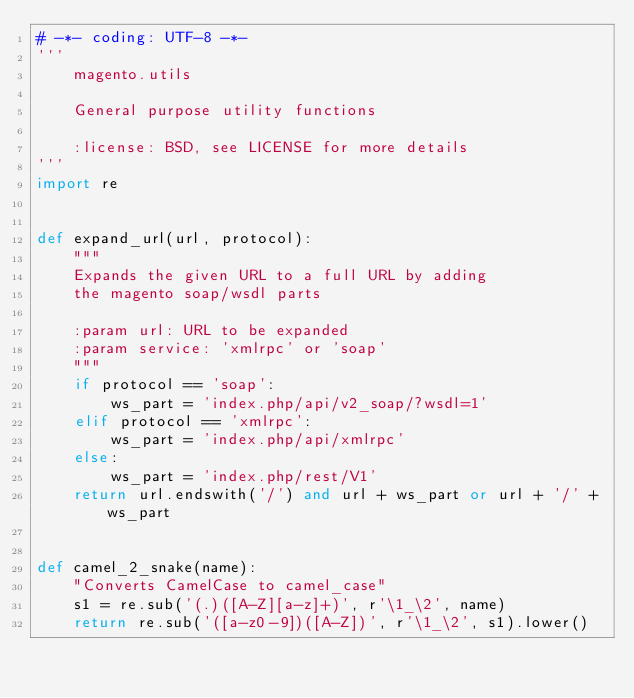<code> <loc_0><loc_0><loc_500><loc_500><_Python_># -*- coding: UTF-8 -*-
'''
    magento.utils

    General purpose utility functions

    :license: BSD, see LICENSE for more details
'''
import re


def expand_url(url, protocol):
    """
    Expands the given URL to a full URL by adding
    the magento soap/wsdl parts

    :param url: URL to be expanded
    :param service: 'xmlrpc' or 'soap'
    """
    if protocol == 'soap':
        ws_part = 'index.php/api/v2_soap/?wsdl=1'
    elif protocol == 'xmlrpc':
        ws_part = 'index.php/api/xmlrpc'
    else:
        ws_part = 'index.php/rest/V1'
    return url.endswith('/') and url + ws_part or url + '/' + ws_part


def camel_2_snake(name):
    "Converts CamelCase to camel_case"
    s1 = re.sub('(.)([A-Z][a-z]+)', r'\1_\2', name)
    return re.sub('([a-z0-9])([A-Z])', r'\1_\2', s1).lower()
</code> 